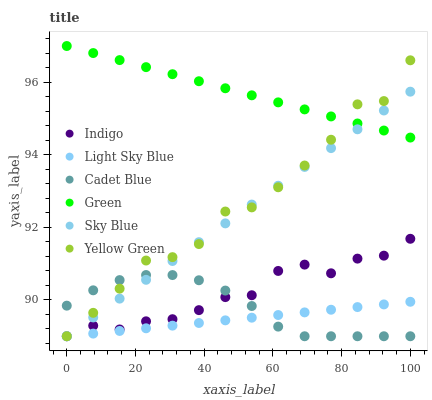Does Light Sky Blue have the minimum area under the curve?
Answer yes or no. Yes. Does Green have the maximum area under the curve?
Answer yes or no. Yes. Does Indigo have the minimum area under the curve?
Answer yes or no. No. Does Indigo have the maximum area under the curve?
Answer yes or no. No. Is Sky Blue the smoothest?
Answer yes or no. Yes. Is Yellow Green the roughest?
Answer yes or no. Yes. Is Indigo the smoothest?
Answer yes or no. No. Is Indigo the roughest?
Answer yes or no. No. Does Cadet Blue have the lowest value?
Answer yes or no. Yes. Does Green have the lowest value?
Answer yes or no. No. Does Green have the highest value?
Answer yes or no. Yes. Does Indigo have the highest value?
Answer yes or no. No. Is Indigo less than Green?
Answer yes or no. Yes. Is Green greater than Indigo?
Answer yes or no. Yes. Does Sky Blue intersect Light Sky Blue?
Answer yes or no. Yes. Is Sky Blue less than Light Sky Blue?
Answer yes or no. No. Is Sky Blue greater than Light Sky Blue?
Answer yes or no. No. Does Indigo intersect Green?
Answer yes or no. No. 